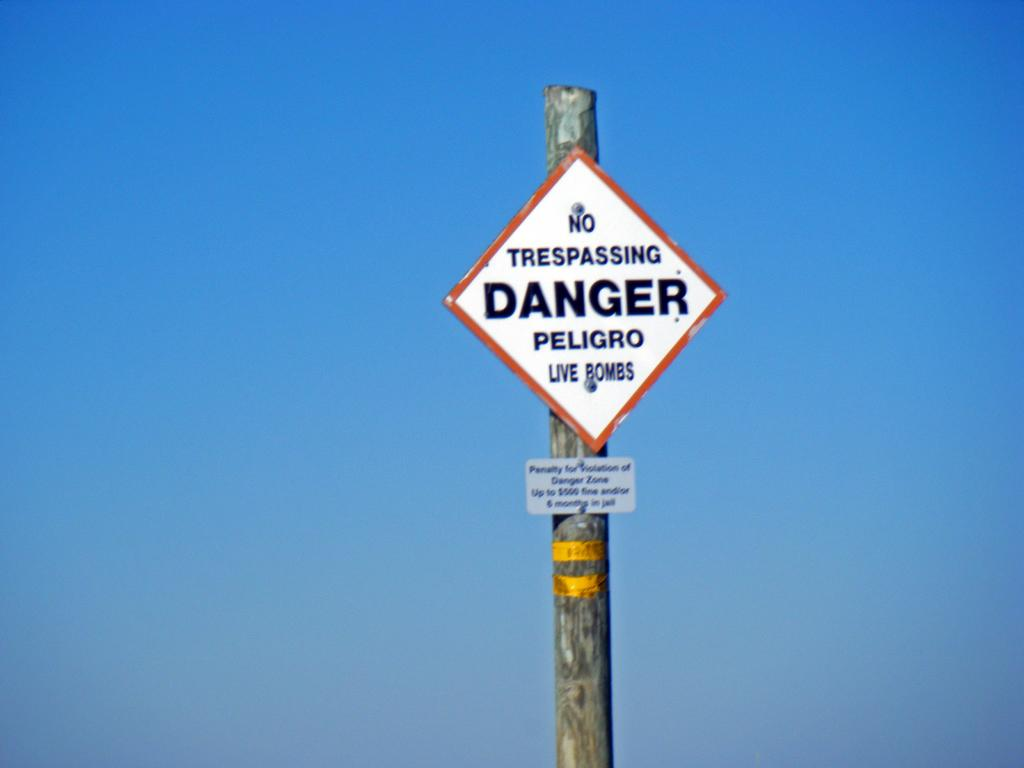<image>
Relay a brief, clear account of the picture shown. a pole that states no trespassing danger in a diamond shape 